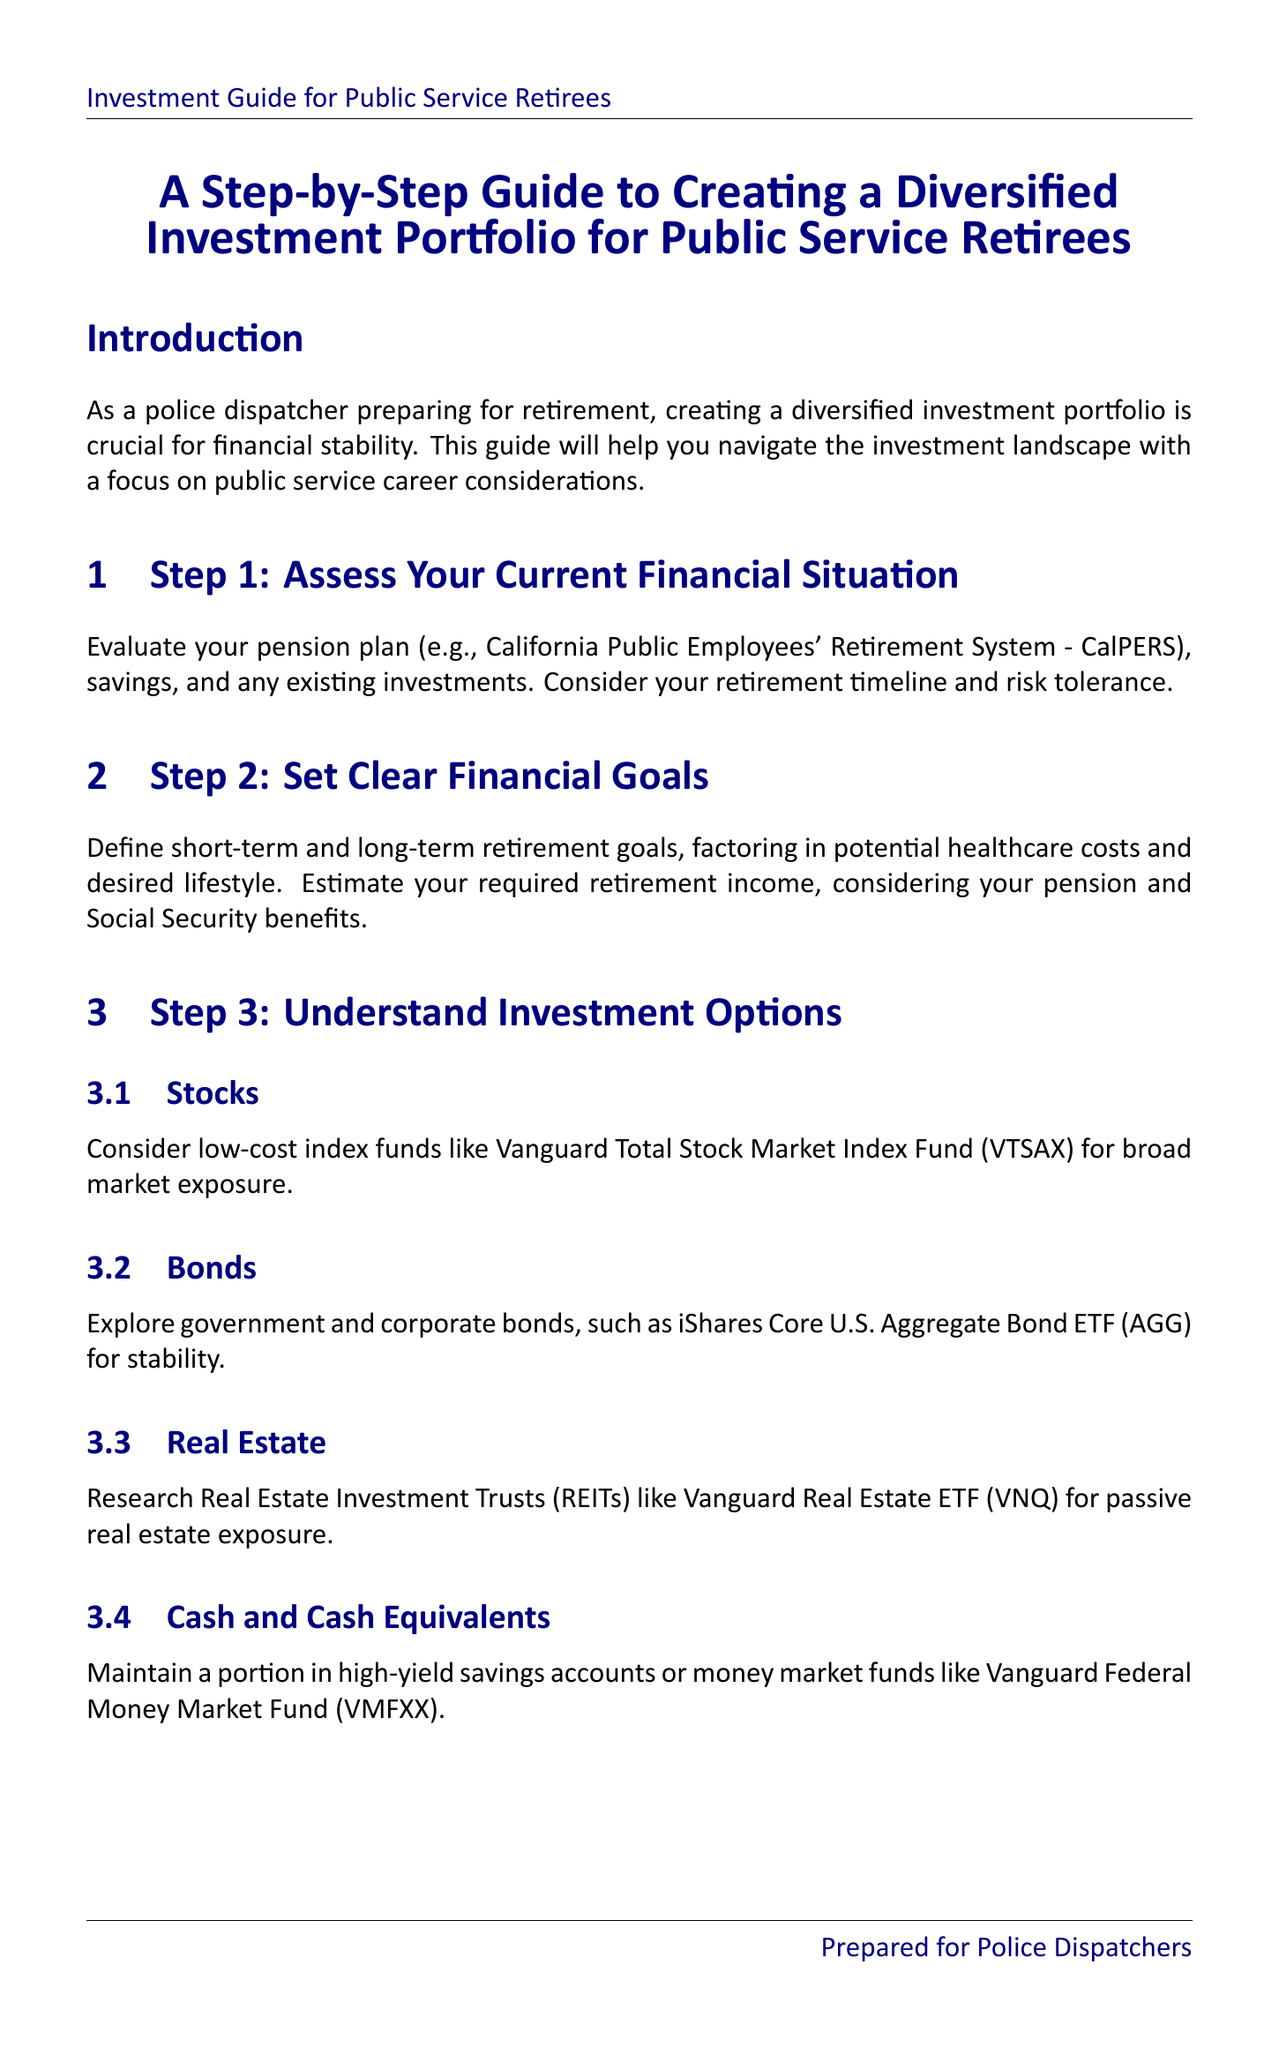What is the title of the document? The title is stated at the beginning of the manual, clearly indicating the focus of the guide.
Answer: A Step-by-Step Guide to Creating a Diversified Investment Portfolio for Public Service Retirees What is the main goal of Step 1? Step 1 focuses on evaluating one's current financial situation, which includes assessing various financial aspects such as pension and savings.
Answer: Assess Your Current Financial Situation What investment option is recommended for stability? The document specifies government and corporate bonds as a recommended investment option for stability under the "Understand Investment Options" section.
Answer: Bonds What is the '110 minus your age' rule related to? This rule is discussed in Step 4, which emphasizes asset allocation based on one's age to determine the percentage of stocks.
Answer: Asset Allocation Which fund aligns with public sector values? The guide suggests selecting public sector-focused funds for alignment with career values, specifically naming one in Step 5.
Answer: Vanguard FTSE Social Index Fund How often should you review your portfolio? The document advises reviewing and rebalancing your portfolio annually or semi-annually, emphasizing the importance of timing in investment management.
Answer: Annually or semi-annually What is a suggested method to start investing? The document mentions a strategy to mitigate timing risks when investing, which encourages a systematic approach.
Answer: Dollar-cost averaging Who should you consider consulting for professional advice? The document recommends seeking out advisors who have specific credentials and experience related to public sector retirement, guiding readers on expert consultation.
Answer: Financial advisor specializing in public sector retirement What is maintained in high-yield savings accounts? The document refers to a portion of investments that should be kept in secure saving options for liquidity and safety.
Answer: Cash and Cash Equivalents 